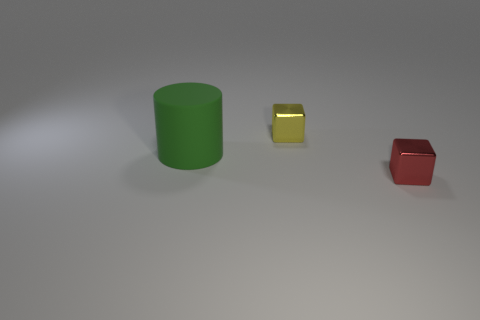Add 2 green matte cylinders. How many objects exist? 5 Subtract all yellow cubes. How many cubes are left? 1 Subtract all cylinders. How many objects are left? 2 Add 3 metal things. How many metal things are left? 5 Add 2 large yellow matte cubes. How many large yellow matte cubes exist? 2 Subtract 0 purple spheres. How many objects are left? 3 Subtract all blue cubes. Subtract all green cylinders. How many cubes are left? 2 Subtract all green cylinders. How many yellow blocks are left? 1 Subtract all yellow rubber cubes. Subtract all metal objects. How many objects are left? 1 